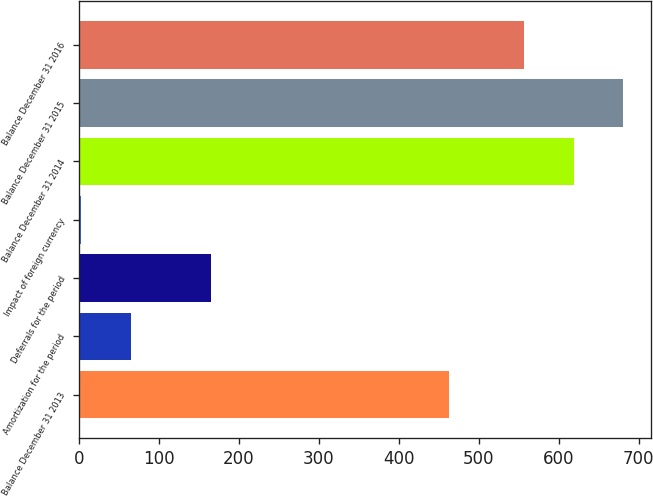<chart> <loc_0><loc_0><loc_500><loc_500><bar_chart><fcel>Balance December 31 2013<fcel>Amortization for the period<fcel>Deferrals for the period<fcel>Impact of foreign currency<fcel>Balance December 31 2014<fcel>Balance December 31 2015<fcel>Balance December 31 2016<nl><fcel>463<fcel>64.8<fcel>165<fcel>3<fcel>618.8<fcel>680.6<fcel>557<nl></chart> 